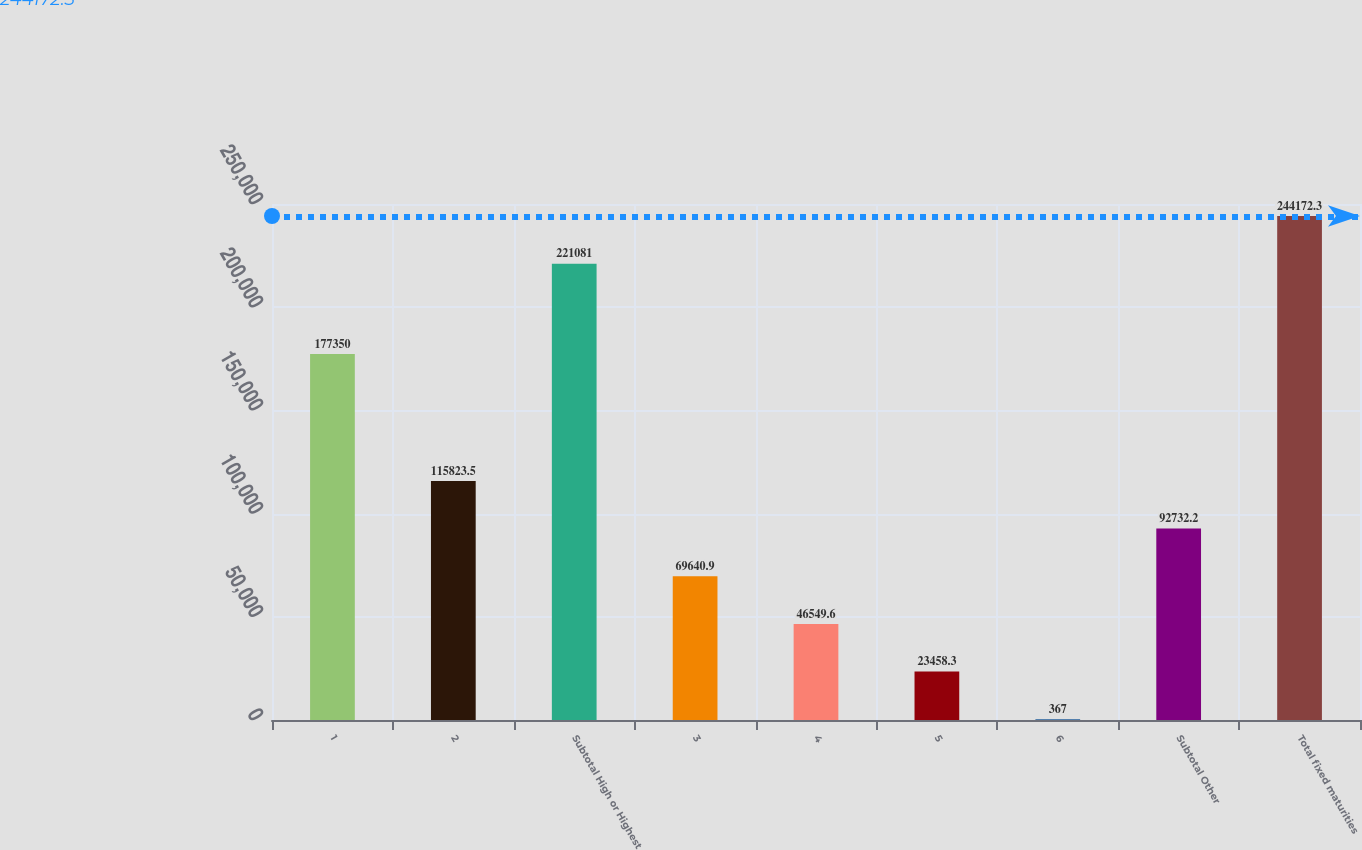Convert chart. <chart><loc_0><loc_0><loc_500><loc_500><bar_chart><fcel>1<fcel>2<fcel>Subtotal High or Highest<fcel>3<fcel>4<fcel>5<fcel>6<fcel>Subtotal Other<fcel>Total fixed maturities<nl><fcel>177350<fcel>115824<fcel>221081<fcel>69640.9<fcel>46549.6<fcel>23458.3<fcel>367<fcel>92732.2<fcel>244172<nl></chart> 